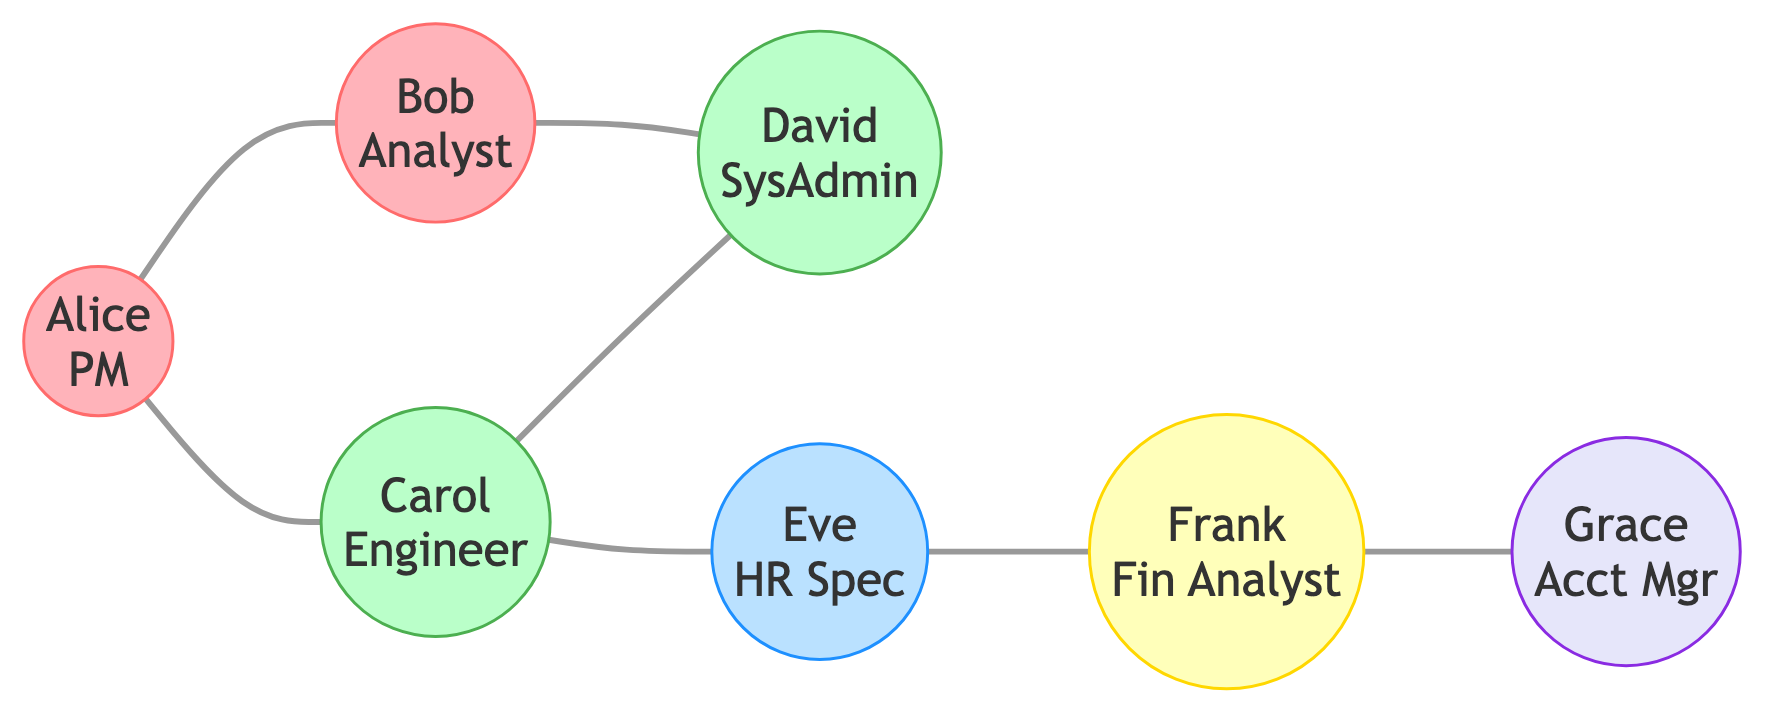What is the total number of nodes in the diagram? To find the total number of nodes, we count each individual entity represented in the diagram. There are seven distinct individuals listed: Alice, Bob, Carol, David, Eve, Frank, and Grace.
Answer: 7 Which two nodes share a direct connection with Alice? By examining the edges connected to Alice, we see she has direct connections to Bob and Carol. Thus, these two nodes share a direct connection with her.
Answer: Bob, Carol How many edges are present in the graph? An edge represents a relationship or connection between two nodes. By counting each line connecting pairs of individuals, we find there are seven edges in total in the graph.
Answer: 7 Who is the Human Resources Specialist? The role of Human Resources Specialist is held by Eve, as noted in the node labels.
Answer: Eve Which team has the highest number of interconnections among its members? To determine which team has the most interconnections, we need to assess the edges adjacent to members of each team. The Marketing team (Alice and Bob) and the IT team (Carol and David) both have multiple interconnections. However, connections outside their own teams also contribute, leading to a more complex interaction overview. The IT team has indirect connections through Carol to Eve, making IT the team with the highest number of interconnections overall.
Answer: IT What role does Grace fulfill in the organization? By looking directly at the node label for Grace, her role is identified as Account Manager.
Answer: Account Manager Which team does not have any direct connections to the Finance department? By analyzing the connections, we see the Finance department only interacts with Eve (from HR) and Grace. No members of the Finance team (Frank) connect directly with any member from the IT or Marketing teams, indicating that both IT and Marketing lack direct connections to Finance. Thus, we have both teams as eligible responses. However, the more accurate answer is the IT team, as it has no link to Frank at all.
Answer: IT 